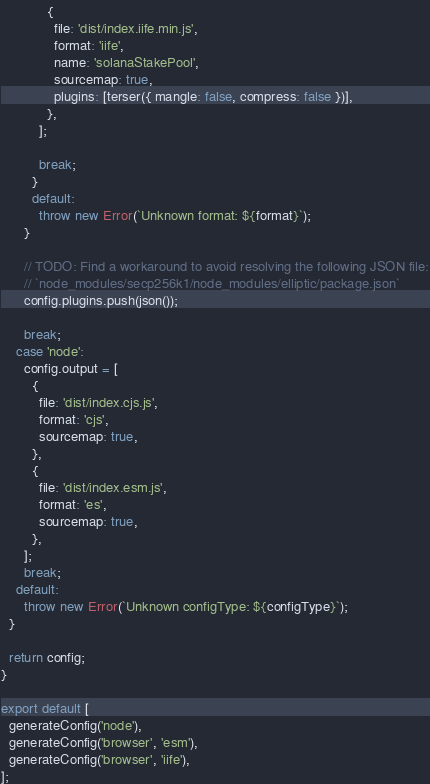<code> <loc_0><loc_0><loc_500><loc_500><_JavaScript_>            {
              file: 'dist/index.iife.min.js',
              format: 'iife',
              name: 'solanaStakePool',
              sourcemap: true,
              plugins: [terser({ mangle: false, compress: false })],
            },
          ];

          break;
        }
        default:
          throw new Error(`Unknown format: ${format}`);
      }

      // TODO: Find a workaround to avoid resolving the following JSON file:
      // `node_modules/secp256k1/node_modules/elliptic/package.json`
      config.plugins.push(json());

      break;
    case 'node':
      config.output = [
        {
          file: 'dist/index.cjs.js',
          format: 'cjs',
          sourcemap: true,
        },
        {
          file: 'dist/index.esm.js',
          format: 'es',
          sourcemap: true,
        },
      ];
      break;
    default:
      throw new Error(`Unknown configType: ${configType}`);
  }

  return config;
}

export default [
  generateConfig('node'),
  generateConfig('browser', 'esm'),
  generateConfig('browser', 'iife'),
];
</code> 